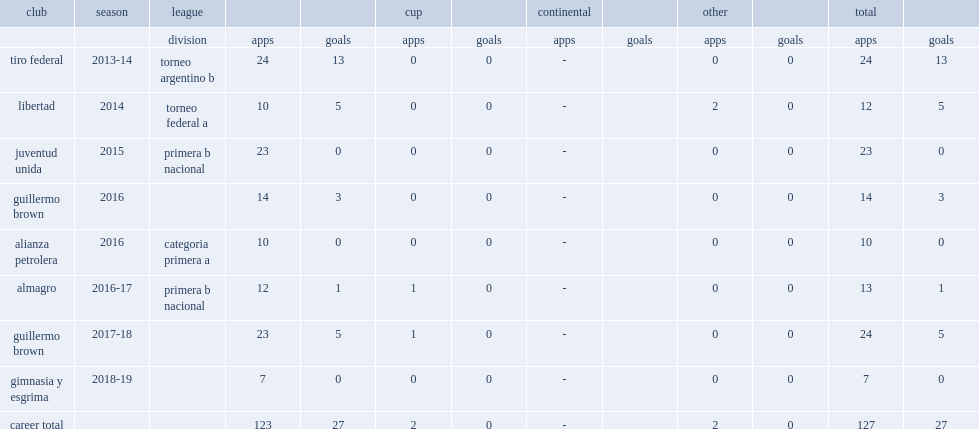Which club did acosta play for in 2016? Guillermo brown. 